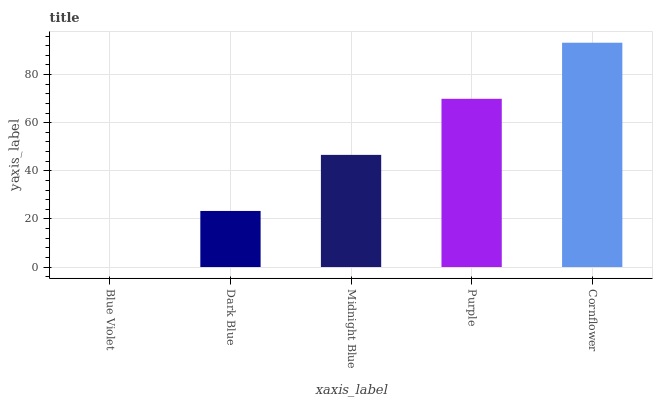Is Dark Blue the minimum?
Answer yes or no. No. Is Dark Blue the maximum?
Answer yes or no. No. Is Dark Blue greater than Blue Violet?
Answer yes or no. Yes. Is Blue Violet less than Dark Blue?
Answer yes or no. Yes. Is Blue Violet greater than Dark Blue?
Answer yes or no. No. Is Dark Blue less than Blue Violet?
Answer yes or no. No. Is Midnight Blue the high median?
Answer yes or no. Yes. Is Midnight Blue the low median?
Answer yes or no. Yes. Is Blue Violet the high median?
Answer yes or no. No. Is Blue Violet the low median?
Answer yes or no. No. 